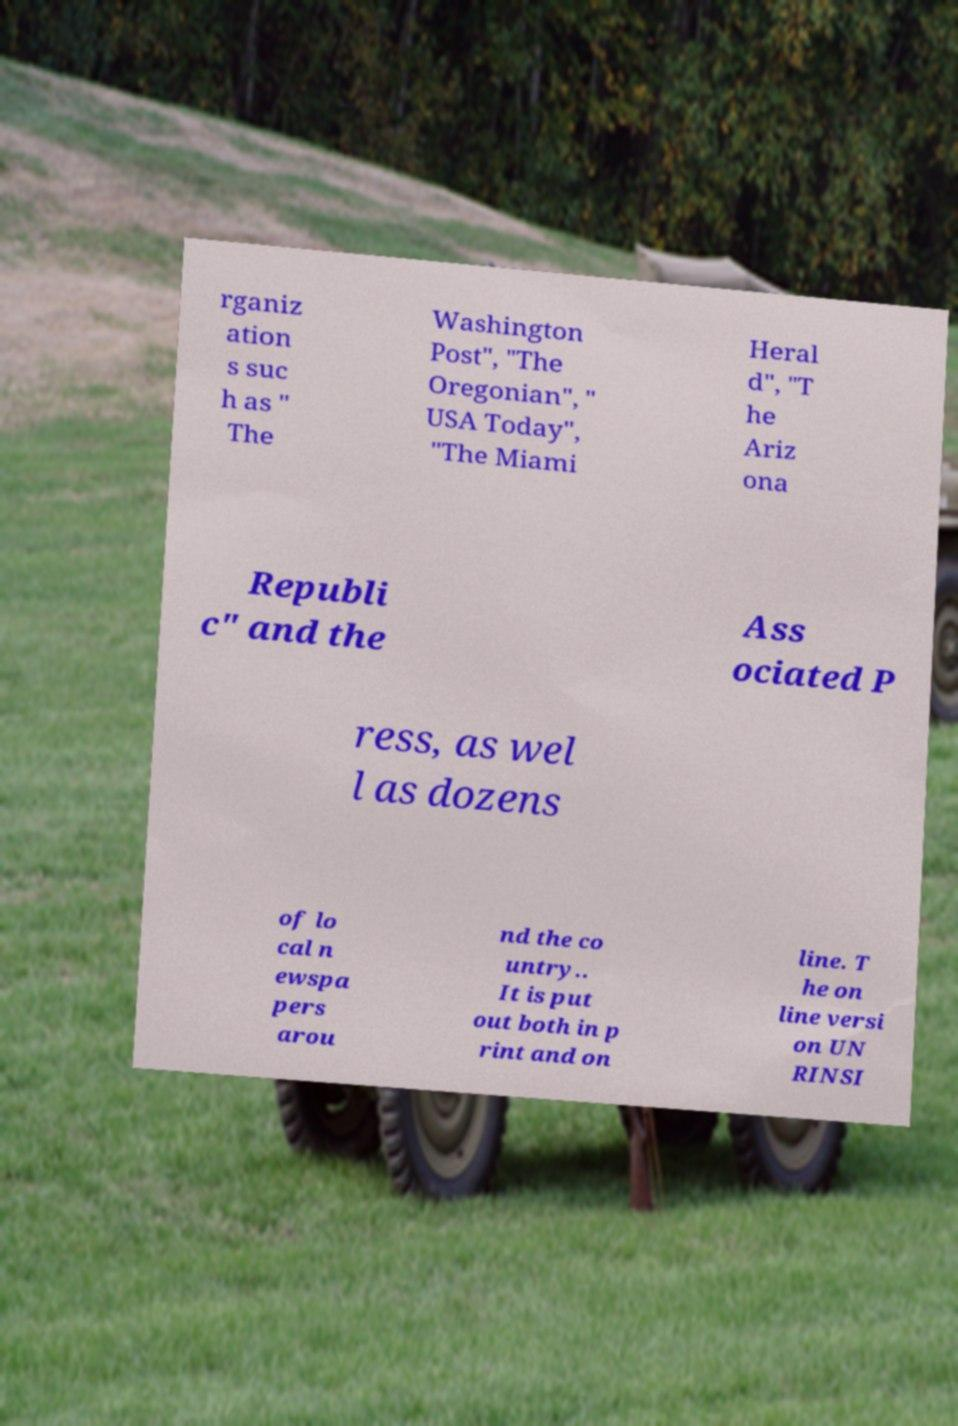For documentation purposes, I need the text within this image transcribed. Could you provide that? rganiz ation s suc h as " The Washington Post", "The Oregonian", " USA Today", "The Miami Heral d", "T he Ariz ona Republi c" and the Ass ociated P ress, as wel l as dozens of lo cal n ewspa pers arou nd the co untry.. It is put out both in p rint and on line. T he on line versi on UN RINSI 